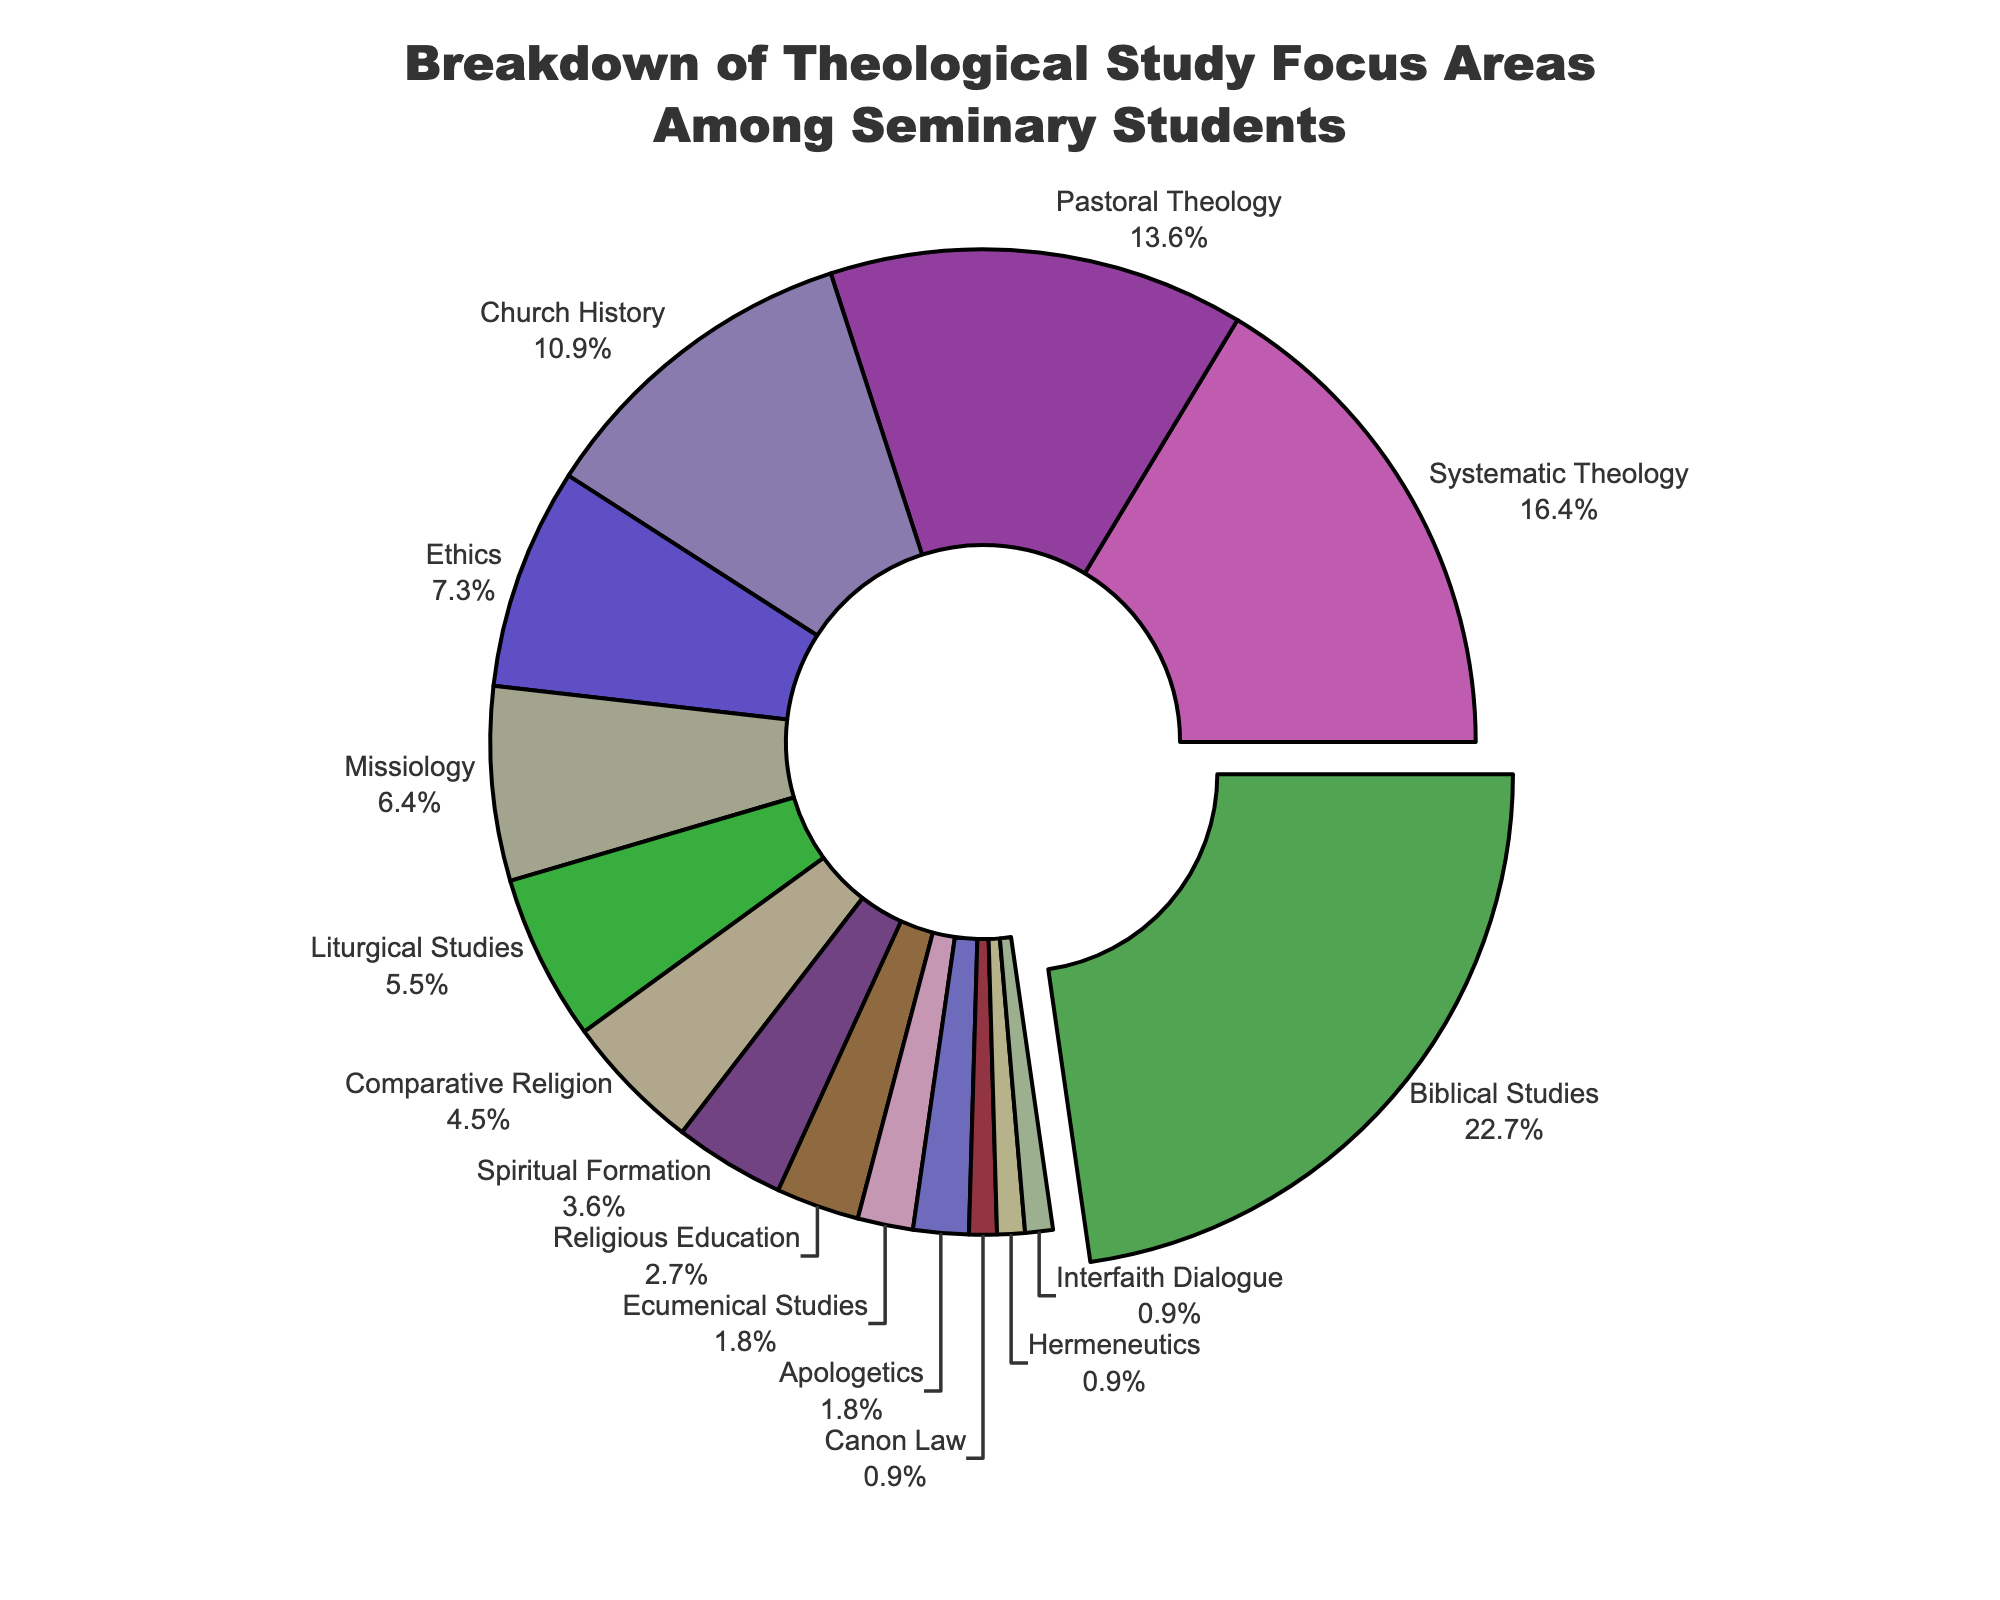What percentage of students focus on Systematic Theology and Church History combined? Add the percentages of students focusing on Systematic Theology (18%) and Church History (12%) to get the combined total. 18% + 12% = 30%
Answer: 30% Which focus area has the smallest percentage of students? Identify the focus area with the lowest percentage on the chart. Canon Law, Hermeneutics, and Interfaith Dialogue each have 1%, but this is not smaller than others listed.
Answer: Canon Law, Hermeneutics, Interfaith Dialogue Are more students focused on Missiology compared to Liturgical Studies? Compare the percentages of students focusing on Missiology (7%) and Liturgical Studies (6%). Since 7% > 6%, more students focus on Missiology.
Answer: Yes What is the visual difference between Biblical Studies and Apologetics in the pie chart? Biblical Studies' segment is highlighted by a pull-out effect and is the largest segment, while Apologetics is among the smallest segments with no pull-out effect.
Answer: Size and pull-out effect How many focus areas have a percentage smaller than 5%? Count the segments in the pie chart that have percentages smaller than 5%. Comparative Religion (5%), Spiritual Formation (4%), Religious Education (3%), Ecumenical Studies (2%), Apologetics (2%), Canon Law (1%), Hermeneutics (1%), Interfaith Dialogue (1%).
Answer: 7 Which focus areas together constitute 50% of the total student focus? Sum the percentages starting from the highest until it equals or exceeds 50%. Biblical Studies (25%) + Systematic Theology (18%) + Pastoral Theology (15%) reaches 58%, which is over 50%.
Answer: Biblical Studies, Systematic Theology, Pastoral Theology Is there a focus area that exactly equals the summation of Ecumenical Studies and Canon Law percentages? Add the percentages of Ecumenical Studies (2%) and Canon Law (1%) to find their sum, which is 3%. Religious Education also has 3%.
Answer: Yes, Religious Education 